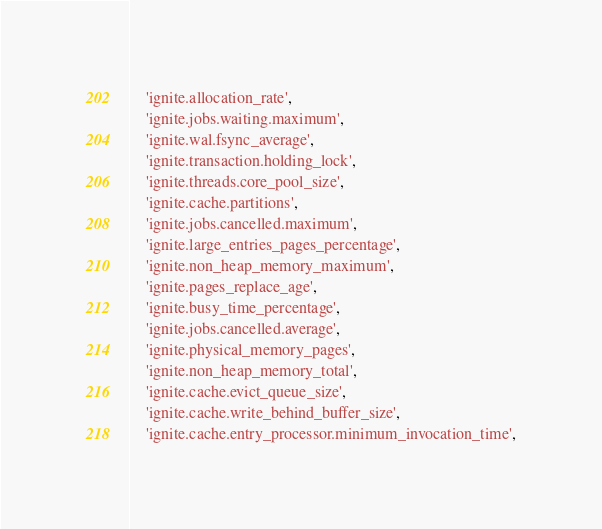<code> <loc_0><loc_0><loc_500><loc_500><_Python_>    'ignite.allocation_rate',
    'ignite.jobs.waiting.maximum',
    'ignite.wal.fsync_average',
    'ignite.transaction.holding_lock',
    'ignite.threads.core_pool_size',
    'ignite.cache.partitions',
    'ignite.jobs.cancelled.maximum',
    'ignite.large_entries_pages_percentage',
    'ignite.non_heap_memory_maximum',
    'ignite.pages_replace_age',
    'ignite.busy_time_percentage',
    'ignite.jobs.cancelled.average',
    'ignite.physical_memory_pages',
    'ignite.non_heap_memory_total',
    'ignite.cache.evict_queue_size',
    'ignite.cache.write_behind_buffer_size',
    'ignite.cache.entry_processor.minimum_invocation_time',</code> 